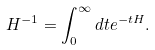<formula> <loc_0><loc_0><loc_500><loc_500>H ^ { - 1 } = \int _ { 0 } ^ { \infty } d t e ^ { - t H } .</formula> 